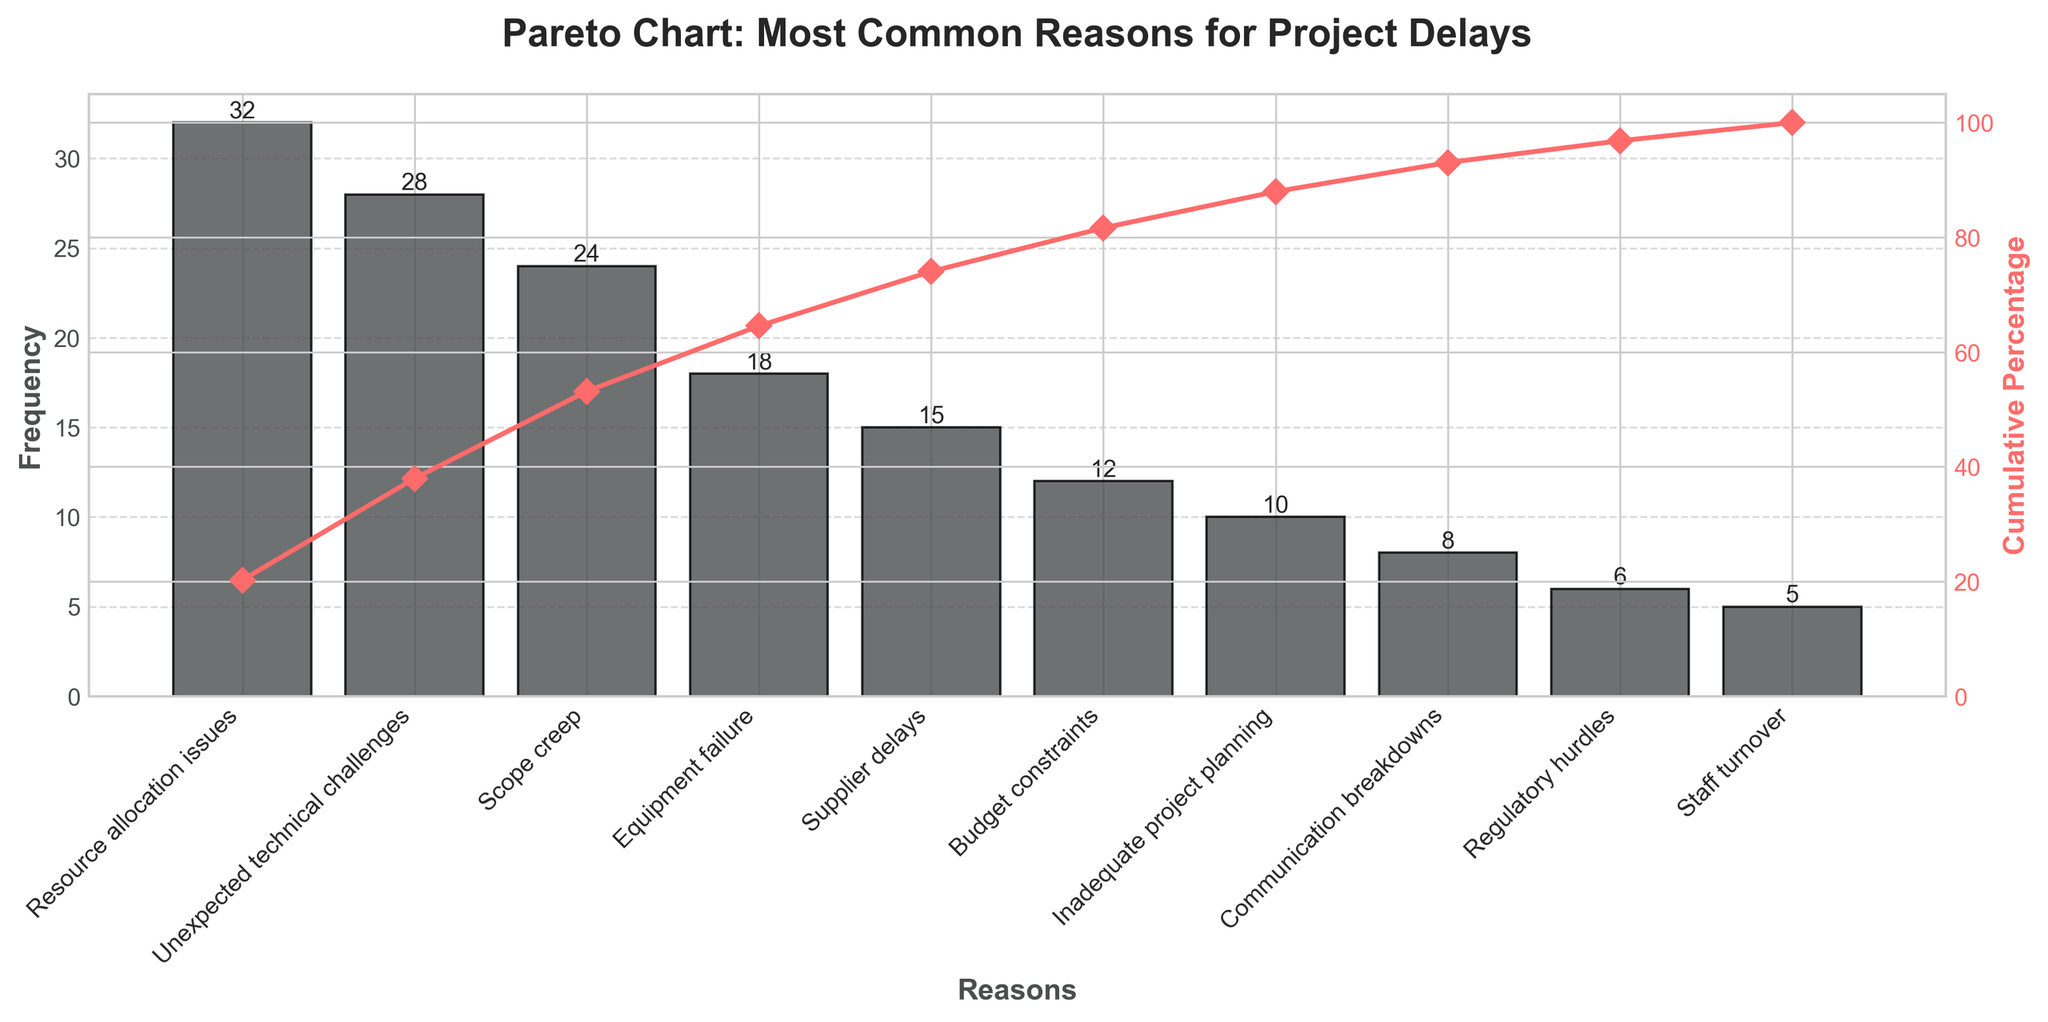What's the title of the figure? The title of the figure is displayed at the top and reads, "Pareto Chart: Most Common Reasons for Project Delays."
Answer: Pareto Chart: Most Common Reasons for Project Delays Which reason has the highest frequency? The reason with the highest frequency is indicated by the tallest bar in the chart, which is labeled "Resource allocation issues."
Answer: Resource allocation issues How many reasons have a frequency higher than 20? By examining the bars, we can see that "Resource allocation issues," "Unexpected technical challenges," and "Scope creep" have frequencies higher than 20.
Answer: 3 What is the cumulative percentage of the top 3 reasons for project delays? The cumulative percentage line shows the cumulative sums. The top 3 reasons are "Resource allocation issues," "Unexpected technical challenges," and "Scope creep," and their percentages are summed to obtain the cumulative percentage.
Answer: 64.1% Which color represents the frequency bars? The frequency bars are displayed in a dark gray-like color.
Answer: Dark gray What is the frequency of "Budget constraints"? The bar corresponding to "Budget constraints" is labeled with its frequency, which is 12.
Answer: 12 Compare the frequencies of "Supplier delays" and "Equipment failure." By observing the bars, "Equipment failure" has a frequency of 18, and "Supplier delays" has a frequency of 15.
Answer: Equipment failure (18) is higher than Supplier delays (15) How much higher is the frequency of "Resource allocation issues" compared to "Staff turnover"? The frequency of "Resource allocation issues" is 32, and "Staff turnover" is 5. The difference is calculated by subtracting the smaller frequency from the larger one.
Answer: 27 What percentage of total delays is attributed to "Inadequate project planning" alone? The cumulative percentage line shows the contribution of each reason. "Inadequate project planning" alone corresponds to a specific point on the line.
Answer: 6.7% Identify a reason for project delays with a frequency lower than 10. The bar corresponding to "Staff turnover" shows a frequency of 5, which is lower than 10.
Answer: Staff turnover 